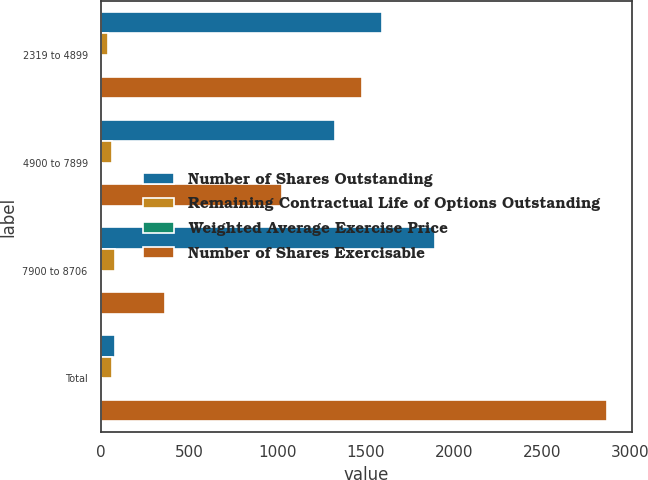<chart> <loc_0><loc_0><loc_500><loc_500><stacked_bar_chart><ecel><fcel>2319 to 4899<fcel>4900 to 7899<fcel>7900 to 8706<fcel>Total<nl><fcel>Number of Shares Outstanding<fcel>1592<fcel>1325<fcel>1892<fcel>81.91<nl><fcel>Remaining Contractual Life of Options Outstanding<fcel>41.06<fcel>63.59<fcel>81.91<fcel>63.34<nl><fcel>Weighted Average Exercise Price<fcel>2.9<fcel>5.7<fcel>9.1<fcel>6.1<nl><fcel>Number of Shares Exercisable<fcel>1479<fcel>1028<fcel>361<fcel>2868<nl></chart> 